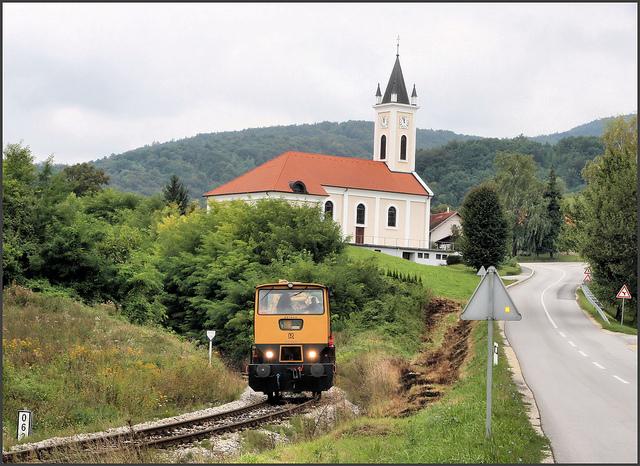Is there a clock in the photo?
Be succinct. Yes. Are any cars on the road?
Answer briefly. No. Is there a church in the background?
Keep it brief. Yes. 